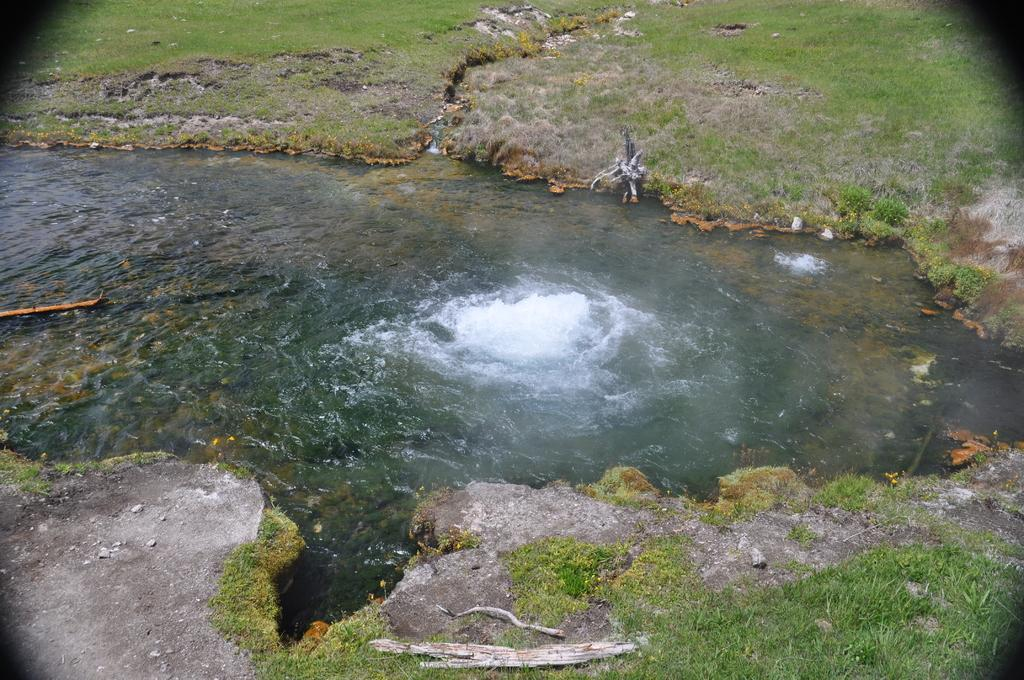What is the main feature in the center of the image? There is a river in the center of the image. What type of vegetation can be seen in the image? There is grass in the image. What type of terrain is present in the image? There is sand in the image. What objects are made of wood in the image? There are wooden sticks in the image. Is there a net used for playing volleyball in the image? There is no net or any indication of a volleyball game in the image. 